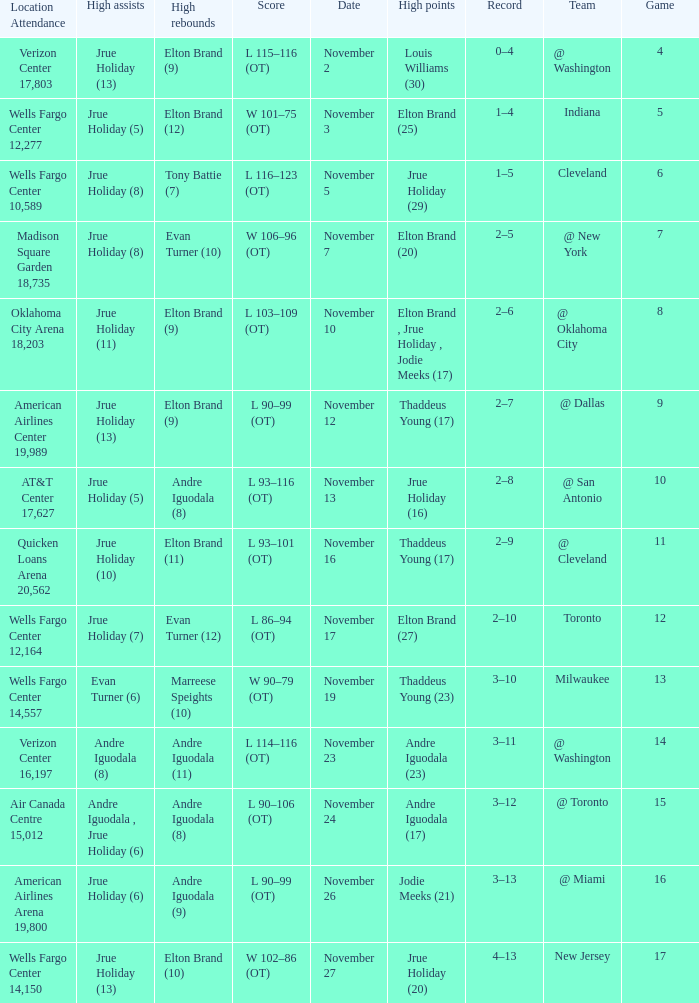How many games are shown for the game where andre iguodala (9) had the high rebounds? 1.0. 